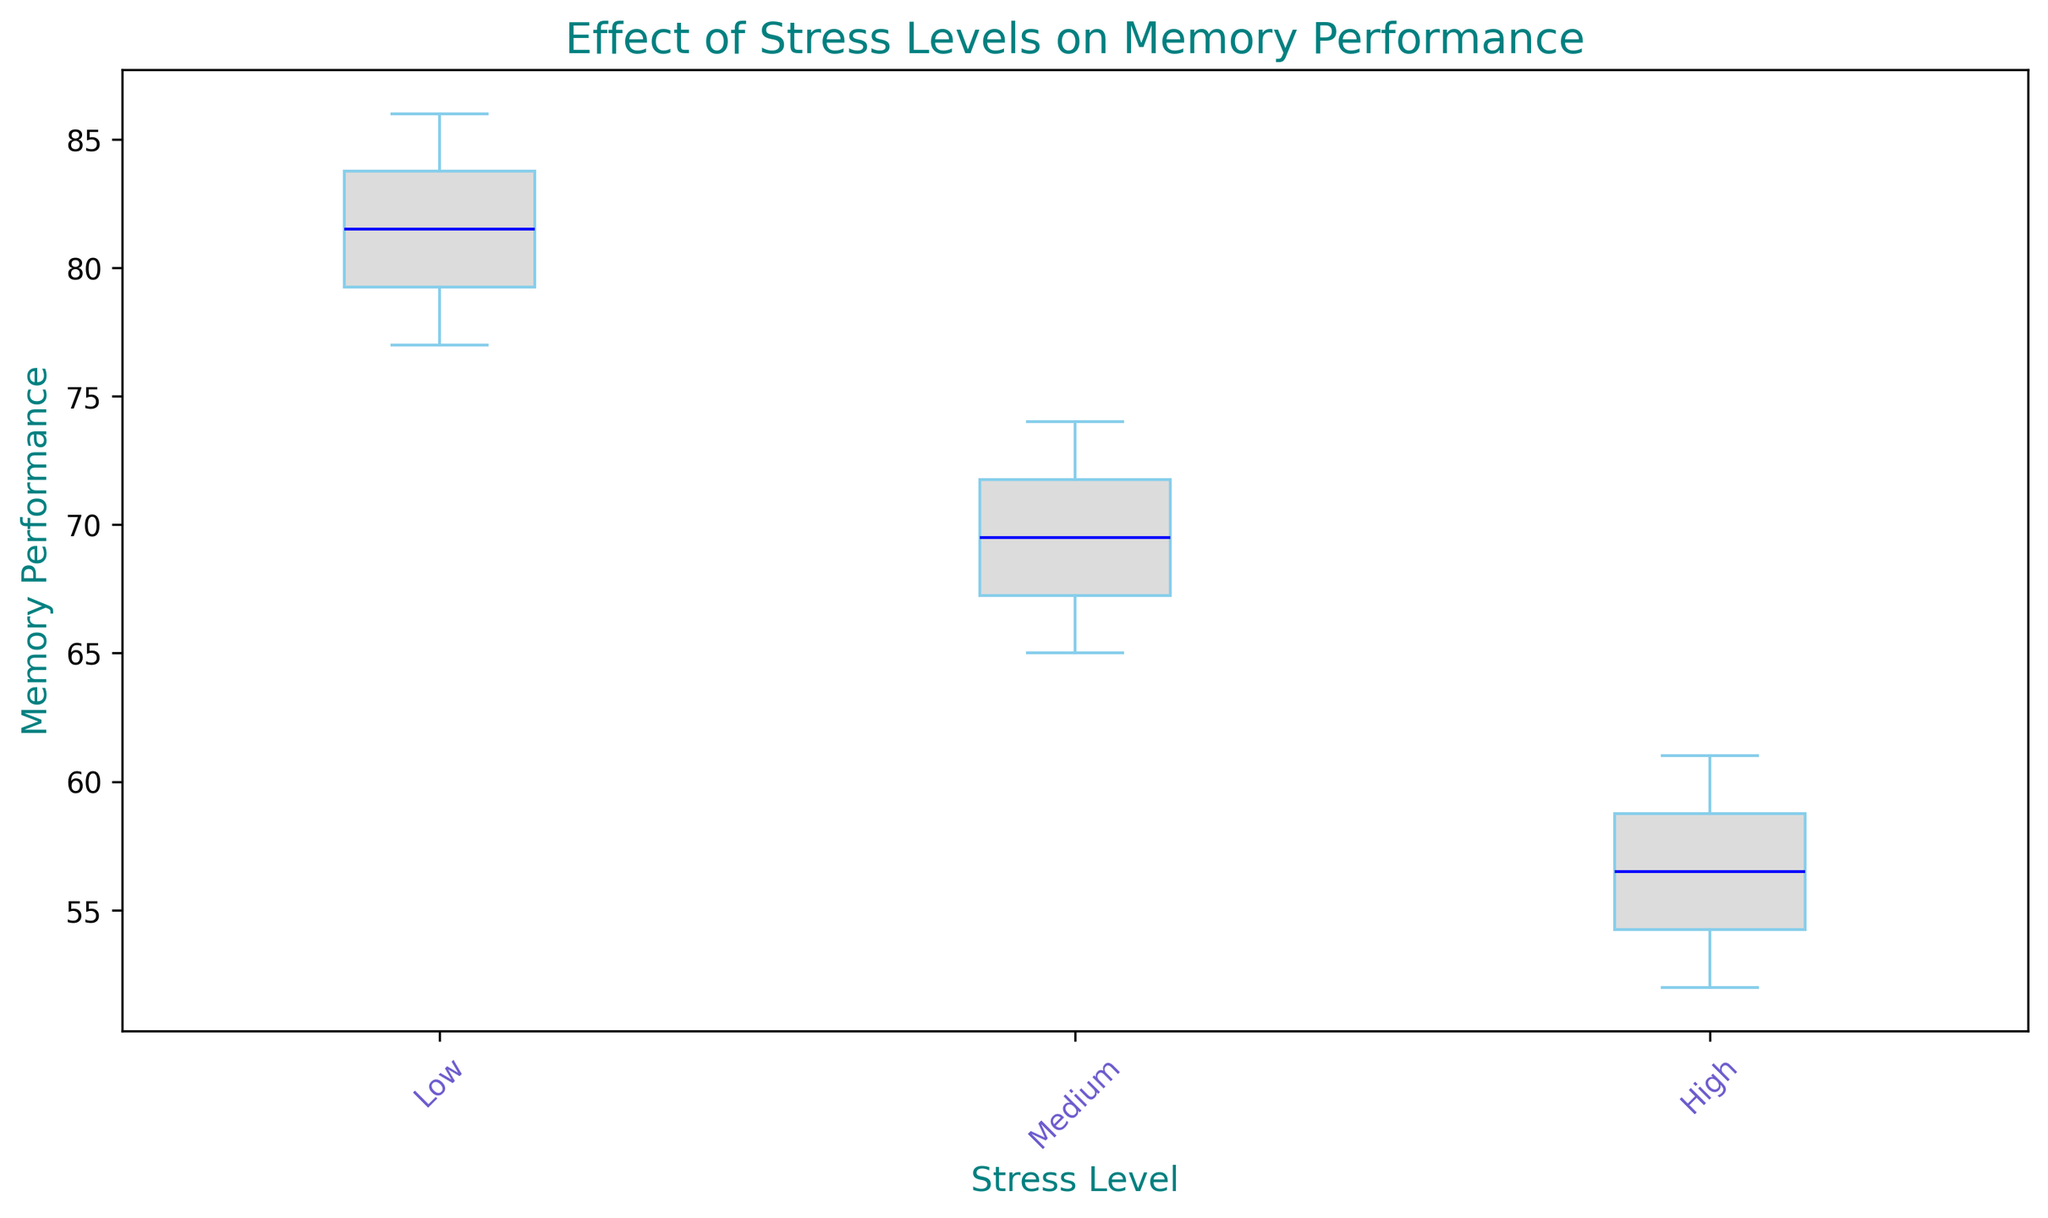What is the median memory performance for each stress level? The box plot displays the median value as a line inside each box. For the low stress level, it is around 82, for the medium stress level it is around 70, and for the high stress level it is around 56.
Answer: 82, 70, 56 Which stress level has the highest variability in memory performance? The variability in memory performance can be inferred from the length of the boxes and the whiskers. The low stress level box has the widest range, indicating the highest variability.
Answer: Low Is there any overlap in memory performance between the different stress levels? Overlap can be observed by checking if any whiskers or boxes of different stress levels are within the same range of values. The whiskers for medium stress levels overlap with the boxes of high stress levels.
Answer: Yes How does the average memory performance compare between the low and high stress levels? Average memory performance can be approximated from the boxes. Low stress level box is significantly higher than the high stress level. The low stress seems to score around mid-80, while high is around mid-50s.
Answer: Low is higher than High What is the interquartile range (IQR) for the medium stress level? The IQR is the range between the first quartile (25th percentile) and the third quartile (75th percentile). It appears the lower bound of the box is around 66, and the upper bound is around 73. Thus, the IQR is about 73-66.
Answer: 7 Which stress level has the highest median memory performance? The median value is shown as a line in the middle of each box. The low stress level has the highest median at around 82.
Answer: Low Are there any outliers in the data for any stress levels? Outliers are typically marked as small circles beyond the whiskers. There appear to be no distinct outliers for any stress level group.
Answer: No What is the range of memory performance observed for the high stress level? The range can be found by subtracting the minimum whisker value from the maximum whisker value. The maximum appears to be around 61 and the minimum around 52, so the range is 61 - 52.
Answer: 9 Is the difference in median memory performance between low and medium stress levels greater than 10 points? The median for low stress is around 82, and for medium, it is around 70. The difference is 82 - 70 = 12, which is greater than 10.
Answer: Yes Based on the plot, which stress level shows the lowest range of variability in memory performance? The range of variability can be identified from the length of the box combined with the whiskers. The box for the medium stress level is the shortest, indicating the lowest variability.
Answer: Medium 